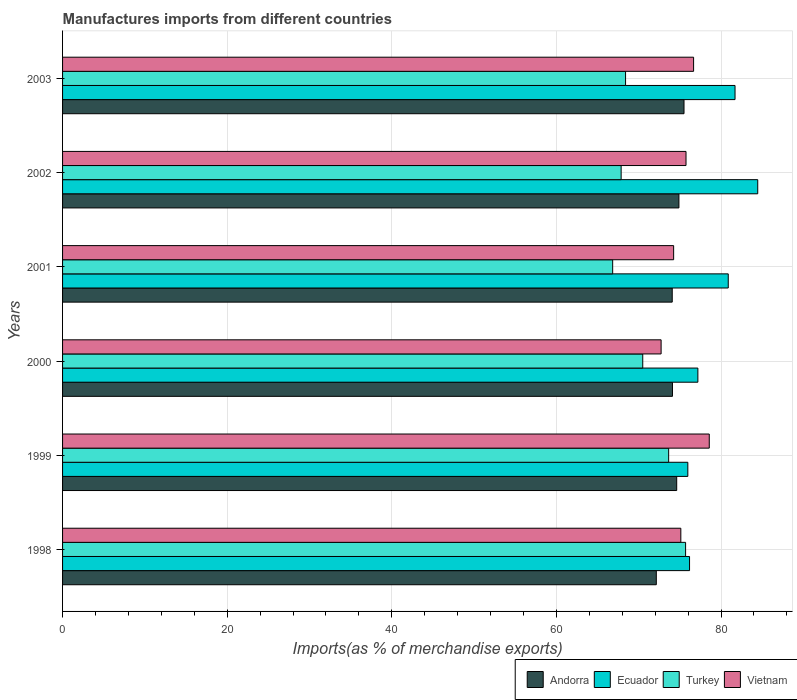Are the number of bars per tick equal to the number of legend labels?
Keep it short and to the point. Yes. Are the number of bars on each tick of the Y-axis equal?
Offer a very short reply. Yes. How many bars are there on the 1st tick from the top?
Provide a short and direct response. 4. How many bars are there on the 3rd tick from the bottom?
Your response must be concise. 4. What is the label of the 2nd group of bars from the top?
Your answer should be very brief. 2002. In how many cases, is the number of bars for a given year not equal to the number of legend labels?
Your answer should be compact. 0. What is the percentage of imports to different countries in Andorra in 2001?
Your answer should be very brief. 74.07. Across all years, what is the maximum percentage of imports to different countries in Andorra?
Offer a terse response. 75.5. Across all years, what is the minimum percentage of imports to different countries in Vietnam?
Offer a very short reply. 72.72. What is the total percentage of imports to different countries in Turkey in the graph?
Make the answer very short. 422.92. What is the difference between the percentage of imports to different countries in Ecuador in 1999 and that in 2003?
Provide a succinct answer. -5.74. What is the difference between the percentage of imports to different countries in Turkey in 1999 and the percentage of imports to different countries in Vietnam in 2002?
Ensure brevity in your answer.  -2.11. What is the average percentage of imports to different countries in Vietnam per year?
Your response must be concise. 75.51. In the year 2000, what is the difference between the percentage of imports to different countries in Ecuador and percentage of imports to different countries in Vietnam?
Keep it short and to the point. 4.47. In how many years, is the percentage of imports to different countries in Vietnam greater than 76 %?
Offer a very short reply. 2. What is the ratio of the percentage of imports to different countries in Ecuador in 1999 to that in 2002?
Offer a very short reply. 0.9. What is the difference between the highest and the second highest percentage of imports to different countries in Vietnam?
Your answer should be very brief. 1.9. What is the difference between the highest and the lowest percentage of imports to different countries in Turkey?
Your answer should be compact. 8.86. In how many years, is the percentage of imports to different countries in Andorra greater than the average percentage of imports to different countries in Andorra taken over all years?
Your answer should be compact. 3. Is the sum of the percentage of imports to different countries in Ecuador in 1999 and 2002 greater than the maximum percentage of imports to different countries in Andorra across all years?
Ensure brevity in your answer.  Yes. What does the 3rd bar from the top in 2003 represents?
Offer a terse response. Ecuador. What does the 4th bar from the bottom in 2000 represents?
Offer a terse response. Vietnam. Is it the case that in every year, the sum of the percentage of imports to different countries in Andorra and percentage of imports to different countries in Turkey is greater than the percentage of imports to different countries in Ecuador?
Offer a terse response. Yes. How many bars are there?
Your answer should be very brief. 24. Are the values on the major ticks of X-axis written in scientific E-notation?
Ensure brevity in your answer.  No. Does the graph contain any zero values?
Ensure brevity in your answer.  No. Where does the legend appear in the graph?
Make the answer very short. Bottom right. What is the title of the graph?
Give a very brief answer. Manufactures imports from different countries. Does "Cameroon" appear as one of the legend labels in the graph?
Offer a very short reply. No. What is the label or title of the X-axis?
Offer a terse response. Imports(as % of merchandise exports). What is the Imports(as % of merchandise exports) of Andorra in 1998?
Offer a terse response. 72.14. What is the Imports(as % of merchandise exports) of Ecuador in 1998?
Keep it short and to the point. 76.18. What is the Imports(as % of merchandise exports) of Turkey in 1998?
Your answer should be very brief. 75.7. What is the Imports(as % of merchandise exports) of Vietnam in 1998?
Provide a succinct answer. 75.12. What is the Imports(as % of merchandise exports) in Andorra in 1999?
Your answer should be compact. 74.62. What is the Imports(as % of merchandise exports) of Ecuador in 1999?
Provide a succinct answer. 75.97. What is the Imports(as % of merchandise exports) of Turkey in 1999?
Ensure brevity in your answer.  73.64. What is the Imports(as % of merchandise exports) in Vietnam in 1999?
Your response must be concise. 78.57. What is the Imports(as % of merchandise exports) of Andorra in 2000?
Offer a terse response. 74.1. What is the Imports(as % of merchandise exports) of Ecuador in 2000?
Make the answer very short. 77.19. What is the Imports(as % of merchandise exports) in Turkey in 2000?
Keep it short and to the point. 70.49. What is the Imports(as % of merchandise exports) in Vietnam in 2000?
Ensure brevity in your answer.  72.72. What is the Imports(as % of merchandise exports) of Andorra in 2001?
Provide a short and direct response. 74.07. What is the Imports(as % of merchandise exports) of Ecuador in 2001?
Offer a very short reply. 80.88. What is the Imports(as % of merchandise exports) in Turkey in 2001?
Give a very brief answer. 66.84. What is the Imports(as % of merchandise exports) of Vietnam in 2001?
Ensure brevity in your answer.  74.24. What is the Imports(as % of merchandise exports) in Andorra in 2002?
Your answer should be compact. 74.88. What is the Imports(as % of merchandise exports) of Ecuador in 2002?
Give a very brief answer. 84.46. What is the Imports(as % of merchandise exports) in Turkey in 2002?
Provide a short and direct response. 67.86. What is the Imports(as % of merchandise exports) of Vietnam in 2002?
Give a very brief answer. 75.75. What is the Imports(as % of merchandise exports) in Andorra in 2003?
Your answer should be compact. 75.5. What is the Imports(as % of merchandise exports) in Ecuador in 2003?
Your answer should be very brief. 81.7. What is the Imports(as % of merchandise exports) of Turkey in 2003?
Provide a short and direct response. 68.4. What is the Imports(as % of merchandise exports) of Vietnam in 2003?
Offer a terse response. 76.67. Across all years, what is the maximum Imports(as % of merchandise exports) in Andorra?
Offer a terse response. 75.5. Across all years, what is the maximum Imports(as % of merchandise exports) in Ecuador?
Offer a terse response. 84.46. Across all years, what is the maximum Imports(as % of merchandise exports) in Turkey?
Your answer should be compact. 75.7. Across all years, what is the maximum Imports(as % of merchandise exports) in Vietnam?
Ensure brevity in your answer.  78.57. Across all years, what is the minimum Imports(as % of merchandise exports) of Andorra?
Make the answer very short. 72.14. Across all years, what is the minimum Imports(as % of merchandise exports) of Ecuador?
Offer a terse response. 75.97. Across all years, what is the minimum Imports(as % of merchandise exports) in Turkey?
Provide a succinct answer. 66.84. Across all years, what is the minimum Imports(as % of merchandise exports) of Vietnam?
Ensure brevity in your answer.  72.72. What is the total Imports(as % of merchandise exports) of Andorra in the graph?
Make the answer very short. 445.31. What is the total Imports(as % of merchandise exports) of Ecuador in the graph?
Offer a terse response. 476.37. What is the total Imports(as % of merchandise exports) of Turkey in the graph?
Make the answer very short. 422.92. What is the total Imports(as % of merchandise exports) of Vietnam in the graph?
Provide a short and direct response. 453.06. What is the difference between the Imports(as % of merchandise exports) of Andorra in 1998 and that in 1999?
Your answer should be very brief. -2.48. What is the difference between the Imports(as % of merchandise exports) of Ecuador in 1998 and that in 1999?
Offer a terse response. 0.21. What is the difference between the Imports(as % of merchandise exports) in Turkey in 1998 and that in 1999?
Make the answer very short. 2.06. What is the difference between the Imports(as % of merchandise exports) in Vietnam in 1998 and that in 1999?
Make the answer very short. -3.45. What is the difference between the Imports(as % of merchandise exports) in Andorra in 1998 and that in 2000?
Your response must be concise. -1.96. What is the difference between the Imports(as % of merchandise exports) in Ecuador in 1998 and that in 2000?
Keep it short and to the point. -1.01. What is the difference between the Imports(as % of merchandise exports) in Turkey in 1998 and that in 2000?
Ensure brevity in your answer.  5.21. What is the difference between the Imports(as % of merchandise exports) of Vietnam in 1998 and that in 2000?
Ensure brevity in your answer.  2.4. What is the difference between the Imports(as % of merchandise exports) of Andorra in 1998 and that in 2001?
Your response must be concise. -1.93. What is the difference between the Imports(as % of merchandise exports) in Ecuador in 1998 and that in 2001?
Your answer should be very brief. -4.7. What is the difference between the Imports(as % of merchandise exports) in Turkey in 1998 and that in 2001?
Offer a very short reply. 8.86. What is the difference between the Imports(as % of merchandise exports) of Vietnam in 1998 and that in 2001?
Your response must be concise. 0.87. What is the difference between the Imports(as % of merchandise exports) in Andorra in 1998 and that in 2002?
Your response must be concise. -2.75. What is the difference between the Imports(as % of merchandise exports) of Ecuador in 1998 and that in 2002?
Ensure brevity in your answer.  -8.28. What is the difference between the Imports(as % of merchandise exports) of Turkey in 1998 and that in 2002?
Give a very brief answer. 7.83. What is the difference between the Imports(as % of merchandise exports) in Vietnam in 1998 and that in 2002?
Provide a short and direct response. -0.63. What is the difference between the Imports(as % of merchandise exports) in Andorra in 1998 and that in 2003?
Ensure brevity in your answer.  -3.37. What is the difference between the Imports(as % of merchandise exports) of Ecuador in 1998 and that in 2003?
Provide a succinct answer. -5.53. What is the difference between the Imports(as % of merchandise exports) in Turkey in 1998 and that in 2003?
Give a very brief answer. 7.29. What is the difference between the Imports(as % of merchandise exports) of Vietnam in 1998 and that in 2003?
Provide a succinct answer. -1.55. What is the difference between the Imports(as % of merchandise exports) in Andorra in 1999 and that in 2000?
Provide a succinct answer. 0.52. What is the difference between the Imports(as % of merchandise exports) of Ecuador in 1999 and that in 2000?
Make the answer very short. -1.22. What is the difference between the Imports(as % of merchandise exports) of Turkey in 1999 and that in 2000?
Give a very brief answer. 3.15. What is the difference between the Imports(as % of merchandise exports) in Vietnam in 1999 and that in 2000?
Keep it short and to the point. 5.85. What is the difference between the Imports(as % of merchandise exports) in Andorra in 1999 and that in 2001?
Offer a terse response. 0.54. What is the difference between the Imports(as % of merchandise exports) in Ecuador in 1999 and that in 2001?
Make the answer very short. -4.91. What is the difference between the Imports(as % of merchandise exports) in Turkey in 1999 and that in 2001?
Offer a very short reply. 6.8. What is the difference between the Imports(as % of merchandise exports) in Vietnam in 1999 and that in 2001?
Make the answer very short. 4.33. What is the difference between the Imports(as % of merchandise exports) in Andorra in 1999 and that in 2002?
Your answer should be very brief. -0.27. What is the difference between the Imports(as % of merchandise exports) of Ecuador in 1999 and that in 2002?
Your response must be concise. -8.49. What is the difference between the Imports(as % of merchandise exports) of Turkey in 1999 and that in 2002?
Your answer should be very brief. 5.77. What is the difference between the Imports(as % of merchandise exports) of Vietnam in 1999 and that in 2002?
Keep it short and to the point. 2.82. What is the difference between the Imports(as % of merchandise exports) in Andorra in 1999 and that in 2003?
Provide a succinct answer. -0.89. What is the difference between the Imports(as % of merchandise exports) of Ecuador in 1999 and that in 2003?
Your response must be concise. -5.74. What is the difference between the Imports(as % of merchandise exports) of Turkey in 1999 and that in 2003?
Your answer should be very brief. 5.24. What is the difference between the Imports(as % of merchandise exports) of Vietnam in 1999 and that in 2003?
Your answer should be compact. 1.9. What is the difference between the Imports(as % of merchandise exports) of Andorra in 2000 and that in 2001?
Your answer should be compact. 0.03. What is the difference between the Imports(as % of merchandise exports) of Ecuador in 2000 and that in 2001?
Make the answer very short. -3.69. What is the difference between the Imports(as % of merchandise exports) of Turkey in 2000 and that in 2001?
Provide a short and direct response. 3.65. What is the difference between the Imports(as % of merchandise exports) in Vietnam in 2000 and that in 2001?
Your response must be concise. -1.52. What is the difference between the Imports(as % of merchandise exports) of Andorra in 2000 and that in 2002?
Keep it short and to the point. -0.78. What is the difference between the Imports(as % of merchandise exports) of Ecuador in 2000 and that in 2002?
Provide a succinct answer. -7.27. What is the difference between the Imports(as % of merchandise exports) of Turkey in 2000 and that in 2002?
Keep it short and to the point. 2.63. What is the difference between the Imports(as % of merchandise exports) of Vietnam in 2000 and that in 2002?
Your answer should be compact. -3.03. What is the difference between the Imports(as % of merchandise exports) of Andorra in 2000 and that in 2003?
Offer a very short reply. -1.4. What is the difference between the Imports(as % of merchandise exports) of Ecuador in 2000 and that in 2003?
Your answer should be compact. -4.52. What is the difference between the Imports(as % of merchandise exports) in Turkey in 2000 and that in 2003?
Your response must be concise. 2.09. What is the difference between the Imports(as % of merchandise exports) of Vietnam in 2000 and that in 2003?
Ensure brevity in your answer.  -3.95. What is the difference between the Imports(as % of merchandise exports) of Andorra in 2001 and that in 2002?
Your answer should be very brief. -0.81. What is the difference between the Imports(as % of merchandise exports) of Ecuador in 2001 and that in 2002?
Offer a terse response. -3.58. What is the difference between the Imports(as % of merchandise exports) in Turkey in 2001 and that in 2002?
Keep it short and to the point. -1.03. What is the difference between the Imports(as % of merchandise exports) in Vietnam in 2001 and that in 2002?
Offer a terse response. -1.5. What is the difference between the Imports(as % of merchandise exports) in Andorra in 2001 and that in 2003?
Your response must be concise. -1.43. What is the difference between the Imports(as % of merchandise exports) of Ecuador in 2001 and that in 2003?
Give a very brief answer. -0.82. What is the difference between the Imports(as % of merchandise exports) of Turkey in 2001 and that in 2003?
Keep it short and to the point. -1.57. What is the difference between the Imports(as % of merchandise exports) of Vietnam in 2001 and that in 2003?
Provide a short and direct response. -2.42. What is the difference between the Imports(as % of merchandise exports) of Andorra in 2002 and that in 2003?
Your answer should be compact. -0.62. What is the difference between the Imports(as % of merchandise exports) of Ecuador in 2002 and that in 2003?
Ensure brevity in your answer.  2.76. What is the difference between the Imports(as % of merchandise exports) in Turkey in 2002 and that in 2003?
Provide a short and direct response. -0.54. What is the difference between the Imports(as % of merchandise exports) of Vietnam in 2002 and that in 2003?
Offer a terse response. -0.92. What is the difference between the Imports(as % of merchandise exports) of Andorra in 1998 and the Imports(as % of merchandise exports) of Ecuador in 1999?
Your answer should be compact. -3.83. What is the difference between the Imports(as % of merchandise exports) in Andorra in 1998 and the Imports(as % of merchandise exports) in Turkey in 1999?
Give a very brief answer. -1.5. What is the difference between the Imports(as % of merchandise exports) of Andorra in 1998 and the Imports(as % of merchandise exports) of Vietnam in 1999?
Your response must be concise. -6.43. What is the difference between the Imports(as % of merchandise exports) of Ecuador in 1998 and the Imports(as % of merchandise exports) of Turkey in 1999?
Provide a succinct answer. 2.54. What is the difference between the Imports(as % of merchandise exports) of Ecuador in 1998 and the Imports(as % of merchandise exports) of Vietnam in 1999?
Offer a terse response. -2.39. What is the difference between the Imports(as % of merchandise exports) in Turkey in 1998 and the Imports(as % of merchandise exports) in Vietnam in 1999?
Make the answer very short. -2.88. What is the difference between the Imports(as % of merchandise exports) in Andorra in 1998 and the Imports(as % of merchandise exports) in Ecuador in 2000?
Keep it short and to the point. -5.05. What is the difference between the Imports(as % of merchandise exports) in Andorra in 1998 and the Imports(as % of merchandise exports) in Turkey in 2000?
Make the answer very short. 1.65. What is the difference between the Imports(as % of merchandise exports) in Andorra in 1998 and the Imports(as % of merchandise exports) in Vietnam in 2000?
Keep it short and to the point. -0.58. What is the difference between the Imports(as % of merchandise exports) of Ecuador in 1998 and the Imports(as % of merchandise exports) of Turkey in 2000?
Keep it short and to the point. 5.69. What is the difference between the Imports(as % of merchandise exports) in Ecuador in 1998 and the Imports(as % of merchandise exports) in Vietnam in 2000?
Your answer should be compact. 3.45. What is the difference between the Imports(as % of merchandise exports) in Turkey in 1998 and the Imports(as % of merchandise exports) in Vietnam in 2000?
Offer a terse response. 2.97. What is the difference between the Imports(as % of merchandise exports) in Andorra in 1998 and the Imports(as % of merchandise exports) in Ecuador in 2001?
Give a very brief answer. -8.74. What is the difference between the Imports(as % of merchandise exports) of Andorra in 1998 and the Imports(as % of merchandise exports) of Turkey in 2001?
Your response must be concise. 5.3. What is the difference between the Imports(as % of merchandise exports) in Andorra in 1998 and the Imports(as % of merchandise exports) in Vietnam in 2001?
Your response must be concise. -2.11. What is the difference between the Imports(as % of merchandise exports) of Ecuador in 1998 and the Imports(as % of merchandise exports) of Turkey in 2001?
Your response must be concise. 9.34. What is the difference between the Imports(as % of merchandise exports) of Ecuador in 1998 and the Imports(as % of merchandise exports) of Vietnam in 2001?
Offer a very short reply. 1.93. What is the difference between the Imports(as % of merchandise exports) in Turkey in 1998 and the Imports(as % of merchandise exports) in Vietnam in 2001?
Make the answer very short. 1.45. What is the difference between the Imports(as % of merchandise exports) in Andorra in 1998 and the Imports(as % of merchandise exports) in Ecuador in 2002?
Ensure brevity in your answer.  -12.32. What is the difference between the Imports(as % of merchandise exports) in Andorra in 1998 and the Imports(as % of merchandise exports) in Turkey in 2002?
Give a very brief answer. 4.27. What is the difference between the Imports(as % of merchandise exports) of Andorra in 1998 and the Imports(as % of merchandise exports) of Vietnam in 2002?
Keep it short and to the point. -3.61. What is the difference between the Imports(as % of merchandise exports) in Ecuador in 1998 and the Imports(as % of merchandise exports) in Turkey in 2002?
Provide a short and direct response. 8.31. What is the difference between the Imports(as % of merchandise exports) in Ecuador in 1998 and the Imports(as % of merchandise exports) in Vietnam in 2002?
Ensure brevity in your answer.  0.43. What is the difference between the Imports(as % of merchandise exports) in Turkey in 1998 and the Imports(as % of merchandise exports) in Vietnam in 2002?
Your response must be concise. -0.05. What is the difference between the Imports(as % of merchandise exports) of Andorra in 1998 and the Imports(as % of merchandise exports) of Ecuador in 2003?
Give a very brief answer. -9.56. What is the difference between the Imports(as % of merchandise exports) of Andorra in 1998 and the Imports(as % of merchandise exports) of Turkey in 2003?
Your answer should be very brief. 3.74. What is the difference between the Imports(as % of merchandise exports) of Andorra in 1998 and the Imports(as % of merchandise exports) of Vietnam in 2003?
Offer a very short reply. -4.53. What is the difference between the Imports(as % of merchandise exports) of Ecuador in 1998 and the Imports(as % of merchandise exports) of Turkey in 2003?
Offer a very short reply. 7.77. What is the difference between the Imports(as % of merchandise exports) of Ecuador in 1998 and the Imports(as % of merchandise exports) of Vietnam in 2003?
Keep it short and to the point. -0.49. What is the difference between the Imports(as % of merchandise exports) of Turkey in 1998 and the Imports(as % of merchandise exports) of Vietnam in 2003?
Provide a short and direct response. -0.97. What is the difference between the Imports(as % of merchandise exports) in Andorra in 1999 and the Imports(as % of merchandise exports) in Ecuador in 2000?
Give a very brief answer. -2.57. What is the difference between the Imports(as % of merchandise exports) of Andorra in 1999 and the Imports(as % of merchandise exports) of Turkey in 2000?
Ensure brevity in your answer.  4.13. What is the difference between the Imports(as % of merchandise exports) in Andorra in 1999 and the Imports(as % of merchandise exports) in Vietnam in 2000?
Offer a terse response. 1.9. What is the difference between the Imports(as % of merchandise exports) of Ecuador in 1999 and the Imports(as % of merchandise exports) of Turkey in 2000?
Your answer should be compact. 5.48. What is the difference between the Imports(as % of merchandise exports) of Ecuador in 1999 and the Imports(as % of merchandise exports) of Vietnam in 2000?
Your answer should be very brief. 3.25. What is the difference between the Imports(as % of merchandise exports) of Turkey in 1999 and the Imports(as % of merchandise exports) of Vietnam in 2000?
Your response must be concise. 0.92. What is the difference between the Imports(as % of merchandise exports) of Andorra in 1999 and the Imports(as % of merchandise exports) of Ecuador in 2001?
Provide a succinct answer. -6.26. What is the difference between the Imports(as % of merchandise exports) in Andorra in 1999 and the Imports(as % of merchandise exports) in Turkey in 2001?
Offer a terse response. 7.78. What is the difference between the Imports(as % of merchandise exports) in Andorra in 1999 and the Imports(as % of merchandise exports) in Vietnam in 2001?
Your response must be concise. 0.37. What is the difference between the Imports(as % of merchandise exports) in Ecuador in 1999 and the Imports(as % of merchandise exports) in Turkey in 2001?
Keep it short and to the point. 9.13. What is the difference between the Imports(as % of merchandise exports) in Ecuador in 1999 and the Imports(as % of merchandise exports) in Vietnam in 2001?
Your answer should be very brief. 1.72. What is the difference between the Imports(as % of merchandise exports) of Turkey in 1999 and the Imports(as % of merchandise exports) of Vietnam in 2001?
Offer a terse response. -0.61. What is the difference between the Imports(as % of merchandise exports) of Andorra in 1999 and the Imports(as % of merchandise exports) of Ecuador in 2002?
Offer a terse response. -9.84. What is the difference between the Imports(as % of merchandise exports) in Andorra in 1999 and the Imports(as % of merchandise exports) in Turkey in 2002?
Provide a succinct answer. 6.75. What is the difference between the Imports(as % of merchandise exports) in Andorra in 1999 and the Imports(as % of merchandise exports) in Vietnam in 2002?
Provide a short and direct response. -1.13. What is the difference between the Imports(as % of merchandise exports) of Ecuador in 1999 and the Imports(as % of merchandise exports) of Turkey in 2002?
Your answer should be very brief. 8.1. What is the difference between the Imports(as % of merchandise exports) of Ecuador in 1999 and the Imports(as % of merchandise exports) of Vietnam in 2002?
Keep it short and to the point. 0.22. What is the difference between the Imports(as % of merchandise exports) in Turkey in 1999 and the Imports(as % of merchandise exports) in Vietnam in 2002?
Keep it short and to the point. -2.11. What is the difference between the Imports(as % of merchandise exports) in Andorra in 1999 and the Imports(as % of merchandise exports) in Ecuador in 2003?
Ensure brevity in your answer.  -7.09. What is the difference between the Imports(as % of merchandise exports) in Andorra in 1999 and the Imports(as % of merchandise exports) in Turkey in 2003?
Make the answer very short. 6.21. What is the difference between the Imports(as % of merchandise exports) in Andorra in 1999 and the Imports(as % of merchandise exports) in Vietnam in 2003?
Your answer should be very brief. -2.05. What is the difference between the Imports(as % of merchandise exports) in Ecuador in 1999 and the Imports(as % of merchandise exports) in Turkey in 2003?
Keep it short and to the point. 7.56. What is the difference between the Imports(as % of merchandise exports) of Ecuador in 1999 and the Imports(as % of merchandise exports) of Vietnam in 2003?
Offer a terse response. -0.7. What is the difference between the Imports(as % of merchandise exports) of Turkey in 1999 and the Imports(as % of merchandise exports) of Vietnam in 2003?
Give a very brief answer. -3.03. What is the difference between the Imports(as % of merchandise exports) of Andorra in 2000 and the Imports(as % of merchandise exports) of Ecuador in 2001?
Offer a very short reply. -6.78. What is the difference between the Imports(as % of merchandise exports) of Andorra in 2000 and the Imports(as % of merchandise exports) of Turkey in 2001?
Offer a very short reply. 7.26. What is the difference between the Imports(as % of merchandise exports) of Andorra in 2000 and the Imports(as % of merchandise exports) of Vietnam in 2001?
Provide a short and direct response. -0.14. What is the difference between the Imports(as % of merchandise exports) of Ecuador in 2000 and the Imports(as % of merchandise exports) of Turkey in 2001?
Provide a short and direct response. 10.35. What is the difference between the Imports(as % of merchandise exports) in Ecuador in 2000 and the Imports(as % of merchandise exports) in Vietnam in 2001?
Offer a very short reply. 2.94. What is the difference between the Imports(as % of merchandise exports) of Turkey in 2000 and the Imports(as % of merchandise exports) of Vietnam in 2001?
Your answer should be compact. -3.75. What is the difference between the Imports(as % of merchandise exports) of Andorra in 2000 and the Imports(as % of merchandise exports) of Ecuador in 2002?
Provide a succinct answer. -10.36. What is the difference between the Imports(as % of merchandise exports) of Andorra in 2000 and the Imports(as % of merchandise exports) of Turkey in 2002?
Ensure brevity in your answer.  6.24. What is the difference between the Imports(as % of merchandise exports) of Andorra in 2000 and the Imports(as % of merchandise exports) of Vietnam in 2002?
Offer a terse response. -1.65. What is the difference between the Imports(as % of merchandise exports) in Ecuador in 2000 and the Imports(as % of merchandise exports) in Turkey in 2002?
Offer a very short reply. 9.32. What is the difference between the Imports(as % of merchandise exports) of Ecuador in 2000 and the Imports(as % of merchandise exports) of Vietnam in 2002?
Make the answer very short. 1.44. What is the difference between the Imports(as % of merchandise exports) in Turkey in 2000 and the Imports(as % of merchandise exports) in Vietnam in 2002?
Offer a very short reply. -5.26. What is the difference between the Imports(as % of merchandise exports) of Andorra in 2000 and the Imports(as % of merchandise exports) of Ecuador in 2003?
Provide a succinct answer. -7.6. What is the difference between the Imports(as % of merchandise exports) of Andorra in 2000 and the Imports(as % of merchandise exports) of Turkey in 2003?
Provide a succinct answer. 5.7. What is the difference between the Imports(as % of merchandise exports) of Andorra in 2000 and the Imports(as % of merchandise exports) of Vietnam in 2003?
Make the answer very short. -2.57. What is the difference between the Imports(as % of merchandise exports) of Ecuador in 2000 and the Imports(as % of merchandise exports) of Turkey in 2003?
Keep it short and to the point. 8.79. What is the difference between the Imports(as % of merchandise exports) of Ecuador in 2000 and the Imports(as % of merchandise exports) of Vietnam in 2003?
Your answer should be very brief. 0.52. What is the difference between the Imports(as % of merchandise exports) of Turkey in 2000 and the Imports(as % of merchandise exports) of Vietnam in 2003?
Your response must be concise. -6.18. What is the difference between the Imports(as % of merchandise exports) in Andorra in 2001 and the Imports(as % of merchandise exports) in Ecuador in 2002?
Offer a terse response. -10.39. What is the difference between the Imports(as % of merchandise exports) of Andorra in 2001 and the Imports(as % of merchandise exports) of Turkey in 2002?
Give a very brief answer. 6.21. What is the difference between the Imports(as % of merchandise exports) in Andorra in 2001 and the Imports(as % of merchandise exports) in Vietnam in 2002?
Your answer should be very brief. -1.67. What is the difference between the Imports(as % of merchandise exports) of Ecuador in 2001 and the Imports(as % of merchandise exports) of Turkey in 2002?
Provide a short and direct response. 13.02. What is the difference between the Imports(as % of merchandise exports) in Ecuador in 2001 and the Imports(as % of merchandise exports) in Vietnam in 2002?
Keep it short and to the point. 5.13. What is the difference between the Imports(as % of merchandise exports) in Turkey in 2001 and the Imports(as % of merchandise exports) in Vietnam in 2002?
Ensure brevity in your answer.  -8.91. What is the difference between the Imports(as % of merchandise exports) in Andorra in 2001 and the Imports(as % of merchandise exports) in Ecuador in 2003?
Your answer should be compact. -7.63. What is the difference between the Imports(as % of merchandise exports) in Andorra in 2001 and the Imports(as % of merchandise exports) in Turkey in 2003?
Your answer should be compact. 5.67. What is the difference between the Imports(as % of merchandise exports) of Andorra in 2001 and the Imports(as % of merchandise exports) of Vietnam in 2003?
Make the answer very short. -2.59. What is the difference between the Imports(as % of merchandise exports) of Ecuador in 2001 and the Imports(as % of merchandise exports) of Turkey in 2003?
Give a very brief answer. 12.48. What is the difference between the Imports(as % of merchandise exports) in Ecuador in 2001 and the Imports(as % of merchandise exports) in Vietnam in 2003?
Make the answer very short. 4.21. What is the difference between the Imports(as % of merchandise exports) in Turkey in 2001 and the Imports(as % of merchandise exports) in Vietnam in 2003?
Ensure brevity in your answer.  -9.83. What is the difference between the Imports(as % of merchandise exports) in Andorra in 2002 and the Imports(as % of merchandise exports) in Ecuador in 2003?
Offer a terse response. -6.82. What is the difference between the Imports(as % of merchandise exports) of Andorra in 2002 and the Imports(as % of merchandise exports) of Turkey in 2003?
Offer a terse response. 6.48. What is the difference between the Imports(as % of merchandise exports) in Andorra in 2002 and the Imports(as % of merchandise exports) in Vietnam in 2003?
Give a very brief answer. -1.78. What is the difference between the Imports(as % of merchandise exports) of Ecuador in 2002 and the Imports(as % of merchandise exports) of Turkey in 2003?
Provide a short and direct response. 16.06. What is the difference between the Imports(as % of merchandise exports) in Ecuador in 2002 and the Imports(as % of merchandise exports) in Vietnam in 2003?
Make the answer very short. 7.79. What is the difference between the Imports(as % of merchandise exports) of Turkey in 2002 and the Imports(as % of merchandise exports) of Vietnam in 2003?
Offer a terse response. -8.8. What is the average Imports(as % of merchandise exports) of Andorra per year?
Give a very brief answer. 74.22. What is the average Imports(as % of merchandise exports) in Ecuador per year?
Give a very brief answer. 79.39. What is the average Imports(as % of merchandise exports) of Turkey per year?
Ensure brevity in your answer.  70.49. What is the average Imports(as % of merchandise exports) of Vietnam per year?
Provide a short and direct response. 75.51. In the year 1998, what is the difference between the Imports(as % of merchandise exports) of Andorra and Imports(as % of merchandise exports) of Ecuador?
Provide a short and direct response. -4.04. In the year 1998, what is the difference between the Imports(as % of merchandise exports) in Andorra and Imports(as % of merchandise exports) in Turkey?
Give a very brief answer. -3.56. In the year 1998, what is the difference between the Imports(as % of merchandise exports) of Andorra and Imports(as % of merchandise exports) of Vietnam?
Offer a very short reply. -2.98. In the year 1998, what is the difference between the Imports(as % of merchandise exports) of Ecuador and Imports(as % of merchandise exports) of Turkey?
Your answer should be compact. 0.48. In the year 1998, what is the difference between the Imports(as % of merchandise exports) in Ecuador and Imports(as % of merchandise exports) in Vietnam?
Your answer should be compact. 1.06. In the year 1998, what is the difference between the Imports(as % of merchandise exports) of Turkey and Imports(as % of merchandise exports) of Vietnam?
Your answer should be very brief. 0.58. In the year 1999, what is the difference between the Imports(as % of merchandise exports) in Andorra and Imports(as % of merchandise exports) in Ecuador?
Offer a very short reply. -1.35. In the year 1999, what is the difference between the Imports(as % of merchandise exports) in Andorra and Imports(as % of merchandise exports) in Turkey?
Your response must be concise. 0.98. In the year 1999, what is the difference between the Imports(as % of merchandise exports) in Andorra and Imports(as % of merchandise exports) in Vietnam?
Your answer should be very brief. -3.95. In the year 1999, what is the difference between the Imports(as % of merchandise exports) of Ecuador and Imports(as % of merchandise exports) of Turkey?
Offer a terse response. 2.33. In the year 1999, what is the difference between the Imports(as % of merchandise exports) of Ecuador and Imports(as % of merchandise exports) of Vietnam?
Offer a very short reply. -2.6. In the year 1999, what is the difference between the Imports(as % of merchandise exports) in Turkey and Imports(as % of merchandise exports) in Vietnam?
Offer a very short reply. -4.93. In the year 2000, what is the difference between the Imports(as % of merchandise exports) in Andorra and Imports(as % of merchandise exports) in Ecuador?
Provide a succinct answer. -3.09. In the year 2000, what is the difference between the Imports(as % of merchandise exports) in Andorra and Imports(as % of merchandise exports) in Turkey?
Offer a terse response. 3.61. In the year 2000, what is the difference between the Imports(as % of merchandise exports) in Andorra and Imports(as % of merchandise exports) in Vietnam?
Your answer should be compact. 1.38. In the year 2000, what is the difference between the Imports(as % of merchandise exports) of Ecuador and Imports(as % of merchandise exports) of Turkey?
Provide a short and direct response. 6.7. In the year 2000, what is the difference between the Imports(as % of merchandise exports) of Ecuador and Imports(as % of merchandise exports) of Vietnam?
Provide a succinct answer. 4.47. In the year 2000, what is the difference between the Imports(as % of merchandise exports) of Turkey and Imports(as % of merchandise exports) of Vietnam?
Keep it short and to the point. -2.23. In the year 2001, what is the difference between the Imports(as % of merchandise exports) in Andorra and Imports(as % of merchandise exports) in Ecuador?
Provide a short and direct response. -6.81. In the year 2001, what is the difference between the Imports(as % of merchandise exports) in Andorra and Imports(as % of merchandise exports) in Turkey?
Your response must be concise. 7.24. In the year 2001, what is the difference between the Imports(as % of merchandise exports) of Andorra and Imports(as % of merchandise exports) of Vietnam?
Keep it short and to the point. -0.17. In the year 2001, what is the difference between the Imports(as % of merchandise exports) in Ecuador and Imports(as % of merchandise exports) in Turkey?
Keep it short and to the point. 14.04. In the year 2001, what is the difference between the Imports(as % of merchandise exports) of Ecuador and Imports(as % of merchandise exports) of Vietnam?
Ensure brevity in your answer.  6.63. In the year 2001, what is the difference between the Imports(as % of merchandise exports) in Turkey and Imports(as % of merchandise exports) in Vietnam?
Give a very brief answer. -7.41. In the year 2002, what is the difference between the Imports(as % of merchandise exports) of Andorra and Imports(as % of merchandise exports) of Ecuador?
Your response must be concise. -9.58. In the year 2002, what is the difference between the Imports(as % of merchandise exports) in Andorra and Imports(as % of merchandise exports) in Turkey?
Offer a very short reply. 7.02. In the year 2002, what is the difference between the Imports(as % of merchandise exports) in Andorra and Imports(as % of merchandise exports) in Vietnam?
Keep it short and to the point. -0.86. In the year 2002, what is the difference between the Imports(as % of merchandise exports) of Ecuador and Imports(as % of merchandise exports) of Turkey?
Provide a short and direct response. 16.6. In the year 2002, what is the difference between the Imports(as % of merchandise exports) in Ecuador and Imports(as % of merchandise exports) in Vietnam?
Offer a very short reply. 8.71. In the year 2002, what is the difference between the Imports(as % of merchandise exports) of Turkey and Imports(as % of merchandise exports) of Vietnam?
Your answer should be very brief. -7.88. In the year 2003, what is the difference between the Imports(as % of merchandise exports) of Andorra and Imports(as % of merchandise exports) of Ecuador?
Ensure brevity in your answer.  -6.2. In the year 2003, what is the difference between the Imports(as % of merchandise exports) of Andorra and Imports(as % of merchandise exports) of Turkey?
Provide a short and direct response. 7.1. In the year 2003, what is the difference between the Imports(as % of merchandise exports) of Andorra and Imports(as % of merchandise exports) of Vietnam?
Provide a succinct answer. -1.16. In the year 2003, what is the difference between the Imports(as % of merchandise exports) of Ecuador and Imports(as % of merchandise exports) of Turkey?
Provide a succinct answer. 13.3. In the year 2003, what is the difference between the Imports(as % of merchandise exports) in Ecuador and Imports(as % of merchandise exports) in Vietnam?
Your answer should be compact. 5.04. In the year 2003, what is the difference between the Imports(as % of merchandise exports) in Turkey and Imports(as % of merchandise exports) in Vietnam?
Offer a very short reply. -8.27. What is the ratio of the Imports(as % of merchandise exports) in Andorra in 1998 to that in 1999?
Keep it short and to the point. 0.97. What is the ratio of the Imports(as % of merchandise exports) in Ecuador in 1998 to that in 1999?
Provide a short and direct response. 1. What is the ratio of the Imports(as % of merchandise exports) of Turkey in 1998 to that in 1999?
Your answer should be very brief. 1.03. What is the ratio of the Imports(as % of merchandise exports) in Vietnam in 1998 to that in 1999?
Provide a short and direct response. 0.96. What is the ratio of the Imports(as % of merchandise exports) of Andorra in 1998 to that in 2000?
Your answer should be compact. 0.97. What is the ratio of the Imports(as % of merchandise exports) in Ecuador in 1998 to that in 2000?
Provide a succinct answer. 0.99. What is the ratio of the Imports(as % of merchandise exports) in Turkey in 1998 to that in 2000?
Offer a terse response. 1.07. What is the ratio of the Imports(as % of merchandise exports) of Vietnam in 1998 to that in 2000?
Give a very brief answer. 1.03. What is the ratio of the Imports(as % of merchandise exports) in Andorra in 1998 to that in 2001?
Keep it short and to the point. 0.97. What is the ratio of the Imports(as % of merchandise exports) of Ecuador in 1998 to that in 2001?
Your answer should be compact. 0.94. What is the ratio of the Imports(as % of merchandise exports) of Turkey in 1998 to that in 2001?
Ensure brevity in your answer.  1.13. What is the ratio of the Imports(as % of merchandise exports) of Vietnam in 1998 to that in 2001?
Offer a terse response. 1.01. What is the ratio of the Imports(as % of merchandise exports) in Andorra in 1998 to that in 2002?
Offer a very short reply. 0.96. What is the ratio of the Imports(as % of merchandise exports) of Ecuador in 1998 to that in 2002?
Your answer should be compact. 0.9. What is the ratio of the Imports(as % of merchandise exports) of Turkey in 1998 to that in 2002?
Your answer should be compact. 1.12. What is the ratio of the Imports(as % of merchandise exports) of Vietnam in 1998 to that in 2002?
Provide a short and direct response. 0.99. What is the ratio of the Imports(as % of merchandise exports) of Andorra in 1998 to that in 2003?
Your answer should be very brief. 0.96. What is the ratio of the Imports(as % of merchandise exports) of Ecuador in 1998 to that in 2003?
Your answer should be very brief. 0.93. What is the ratio of the Imports(as % of merchandise exports) of Turkey in 1998 to that in 2003?
Your response must be concise. 1.11. What is the ratio of the Imports(as % of merchandise exports) in Vietnam in 1998 to that in 2003?
Provide a short and direct response. 0.98. What is the ratio of the Imports(as % of merchandise exports) of Ecuador in 1999 to that in 2000?
Your answer should be very brief. 0.98. What is the ratio of the Imports(as % of merchandise exports) in Turkey in 1999 to that in 2000?
Keep it short and to the point. 1.04. What is the ratio of the Imports(as % of merchandise exports) in Vietnam in 1999 to that in 2000?
Your response must be concise. 1.08. What is the ratio of the Imports(as % of merchandise exports) in Andorra in 1999 to that in 2001?
Your response must be concise. 1.01. What is the ratio of the Imports(as % of merchandise exports) in Ecuador in 1999 to that in 2001?
Give a very brief answer. 0.94. What is the ratio of the Imports(as % of merchandise exports) of Turkey in 1999 to that in 2001?
Ensure brevity in your answer.  1.1. What is the ratio of the Imports(as % of merchandise exports) in Vietnam in 1999 to that in 2001?
Your answer should be compact. 1.06. What is the ratio of the Imports(as % of merchandise exports) of Andorra in 1999 to that in 2002?
Ensure brevity in your answer.  1. What is the ratio of the Imports(as % of merchandise exports) of Ecuador in 1999 to that in 2002?
Your answer should be very brief. 0.9. What is the ratio of the Imports(as % of merchandise exports) in Turkey in 1999 to that in 2002?
Keep it short and to the point. 1.09. What is the ratio of the Imports(as % of merchandise exports) in Vietnam in 1999 to that in 2002?
Your response must be concise. 1.04. What is the ratio of the Imports(as % of merchandise exports) in Andorra in 1999 to that in 2003?
Ensure brevity in your answer.  0.99. What is the ratio of the Imports(as % of merchandise exports) of Ecuador in 1999 to that in 2003?
Make the answer very short. 0.93. What is the ratio of the Imports(as % of merchandise exports) of Turkey in 1999 to that in 2003?
Your answer should be compact. 1.08. What is the ratio of the Imports(as % of merchandise exports) in Vietnam in 1999 to that in 2003?
Provide a short and direct response. 1.02. What is the ratio of the Imports(as % of merchandise exports) in Andorra in 2000 to that in 2001?
Your response must be concise. 1. What is the ratio of the Imports(as % of merchandise exports) of Ecuador in 2000 to that in 2001?
Offer a very short reply. 0.95. What is the ratio of the Imports(as % of merchandise exports) of Turkey in 2000 to that in 2001?
Provide a short and direct response. 1.05. What is the ratio of the Imports(as % of merchandise exports) in Vietnam in 2000 to that in 2001?
Make the answer very short. 0.98. What is the ratio of the Imports(as % of merchandise exports) of Ecuador in 2000 to that in 2002?
Your response must be concise. 0.91. What is the ratio of the Imports(as % of merchandise exports) of Turkey in 2000 to that in 2002?
Provide a short and direct response. 1.04. What is the ratio of the Imports(as % of merchandise exports) in Vietnam in 2000 to that in 2002?
Your answer should be compact. 0.96. What is the ratio of the Imports(as % of merchandise exports) in Andorra in 2000 to that in 2003?
Make the answer very short. 0.98. What is the ratio of the Imports(as % of merchandise exports) of Ecuador in 2000 to that in 2003?
Provide a succinct answer. 0.94. What is the ratio of the Imports(as % of merchandise exports) of Turkey in 2000 to that in 2003?
Give a very brief answer. 1.03. What is the ratio of the Imports(as % of merchandise exports) of Vietnam in 2000 to that in 2003?
Offer a terse response. 0.95. What is the ratio of the Imports(as % of merchandise exports) of Andorra in 2001 to that in 2002?
Give a very brief answer. 0.99. What is the ratio of the Imports(as % of merchandise exports) in Ecuador in 2001 to that in 2002?
Provide a short and direct response. 0.96. What is the ratio of the Imports(as % of merchandise exports) in Turkey in 2001 to that in 2002?
Your answer should be very brief. 0.98. What is the ratio of the Imports(as % of merchandise exports) of Vietnam in 2001 to that in 2002?
Make the answer very short. 0.98. What is the ratio of the Imports(as % of merchandise exports) in Andorra in 2001 to that in 2003?
Keep it short and to the point. 0.98. What is the ratio of the Imports(as % of merchandise exports) in Ecuador in 2001 to that in 2003?
Your response must be concise. 0.99. What is the ratio of the Imports(as % of merchandise exports) in Turkey in 2001 to that in 2003?
Keep it short and to the point. 0.98. What is the ratio of the Imports(as % of merchandise exports) of Vietnam in 2001 to that in 2003?
Provide a short and direct response. 0.97. What is the ratio of the Imports(as % of merchandise exports) of Andorra in 2002 to that in 2003?
Provide a short and direct response. 0.99. What is the ratio of the Imports(as % of merchandise exports) of Ecuador in 2002 to that in 2003?
Offer a terse response. 1.03. What is the ratio of the Imports(as % of merchandise exports) in Turkey in 2002 to that in 2003?
Your answer should be very brief. 0.99. What is the difference between the highest and the second highest Imports(as % of merchandise exports) in Andorra?
Make the answer very short. 0.62. What is the difference between the highest and the second highest Imports(as % of merchandise exports) of Ecuador?
Provide a short and direct response. 2.76. What is the difference between the highest and the second highest Imports(as % of merchandise exports) of Turkey?
Your answer should be very brief. 2.06. What is the difference between the highest and the second highest Imports(as % of merchandise exports) in Vietnam?
Your answer should be compact. 1.9. What is the difference between the highest and the lowest Imports(as % of merchandise exports) of Andorra?
Give a very brief answer. 3.37. What is the difference between the highest and the lowest Imports(as % of merchandise exports) of Ecuador?
Provide a succinct answer. 8.49. What is the difference between the highest and the lowest Imports(as % of merchandise exports) in Turkey?
Your answer should be very brief. 8.86. What is the difference between the highest and the lowest Imports(as % of merchandise exports) in Vietnam?
Provide a succinct answer. 5.85. 